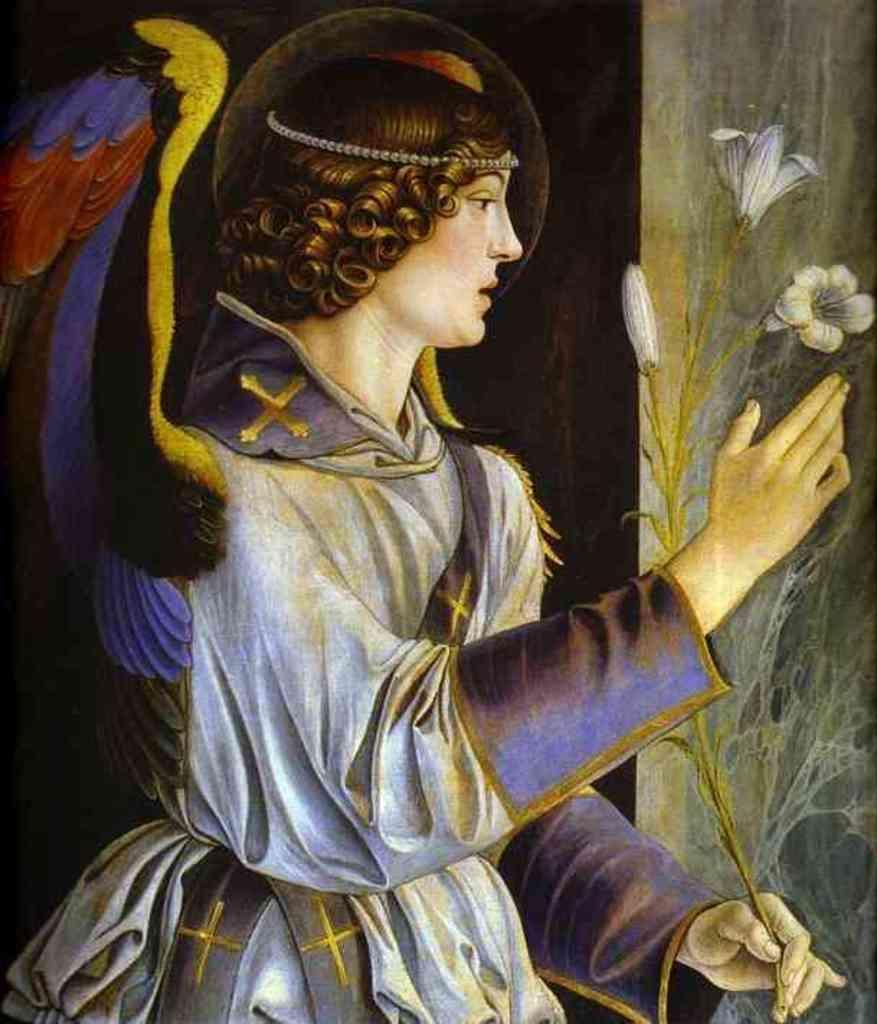Can you describe this image briefly? In this picture we can see a painting, in this painting we can see a person and flowers. 